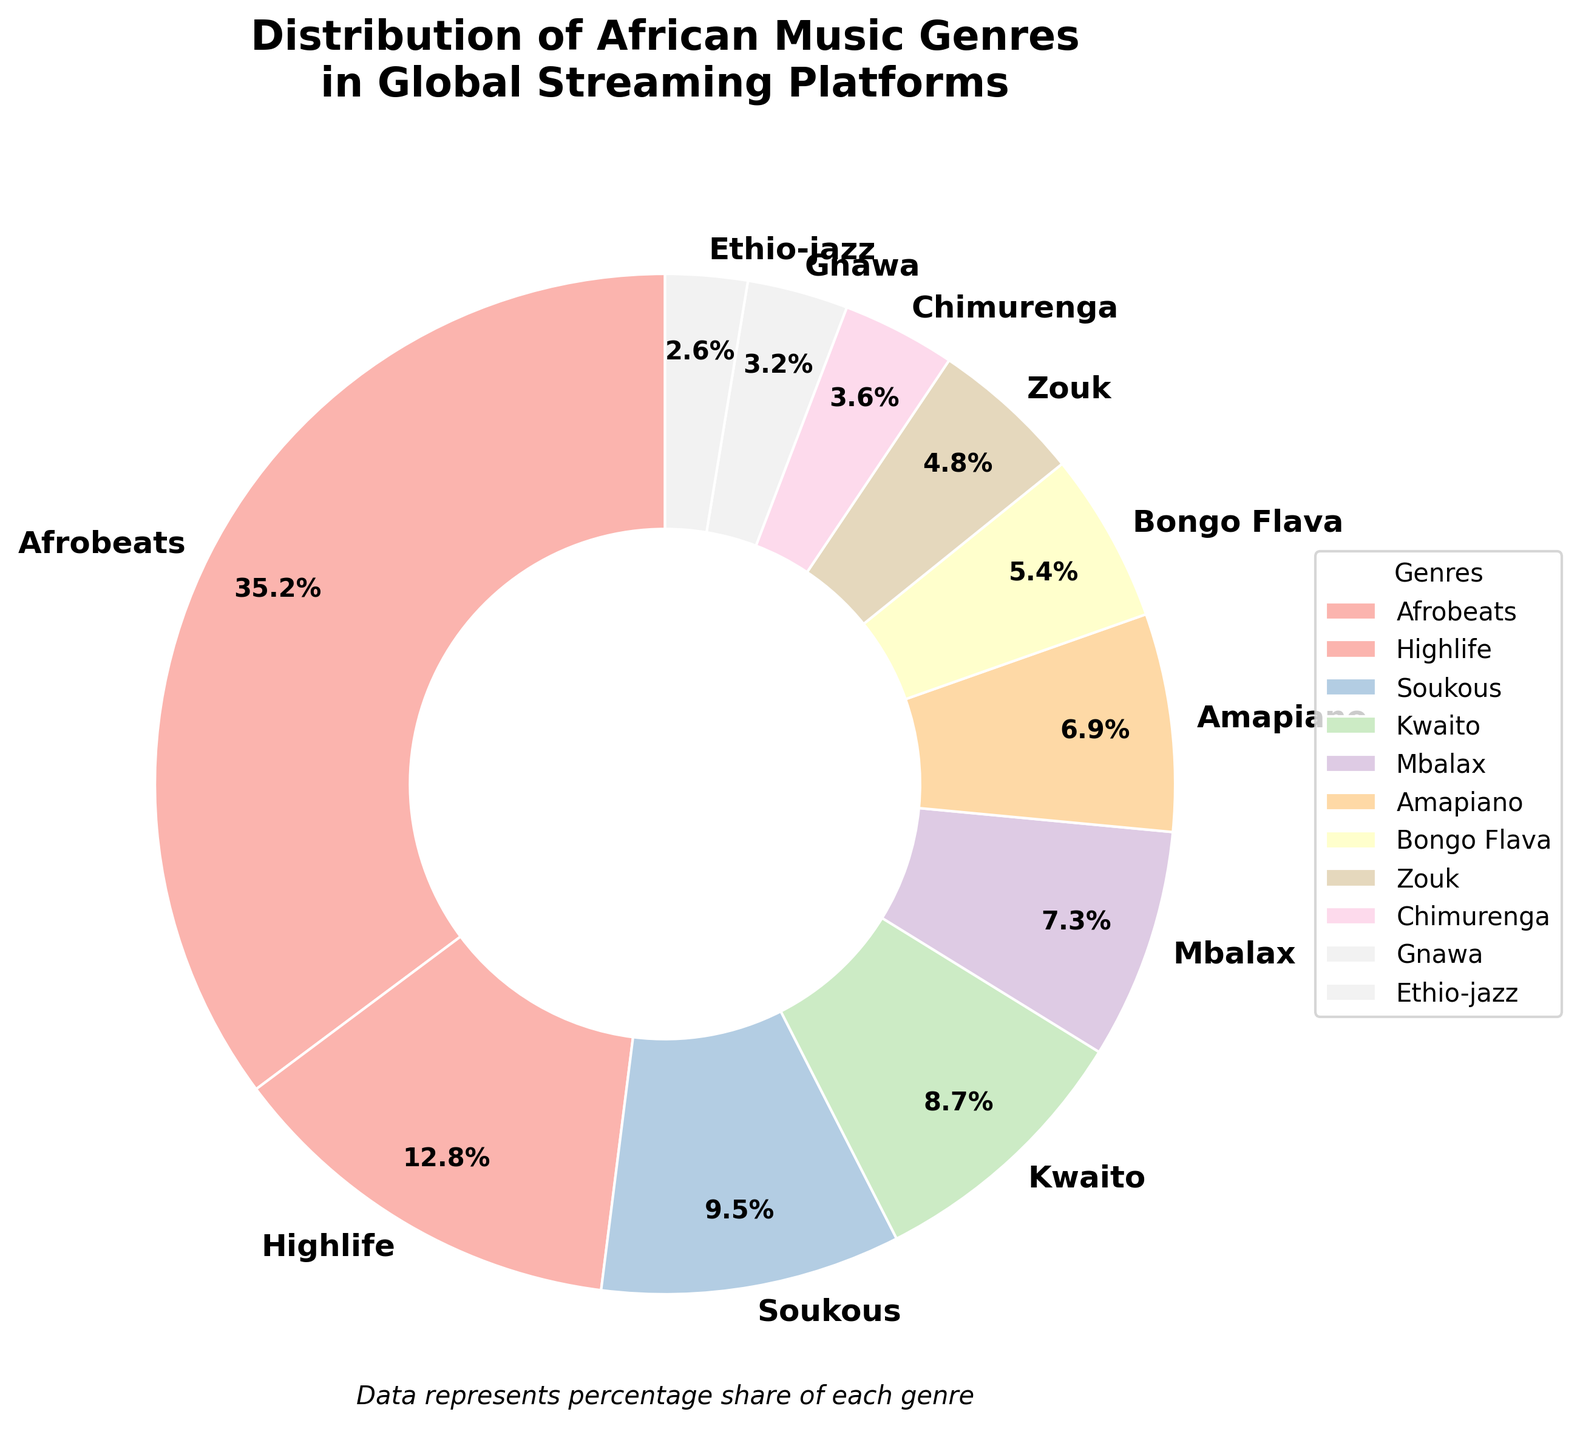Which genre has the highest percentage of distribution in global streaming platforms? The figure shows the percentage distribution of various African music genres. The largest segment of the pie chart represents Afrobeats with 35.2%.
Answer: Afrobeats Which genres have a distribution percentage below 5%? From the lower end of the pie chart, Chimurenga, Gnawa, and Ethio-jazz all have percentages less than 5%: Chimurenga (3.6%), Gnawa (3.2%), and Ethio-jazz (2.6%).
Answer: Chimurenga, Gnawa, Ethio-jazz By how much does the distribution percentage of Highlife exceed that of Kwaito? Highlife has a distribution percentage of 12.8%, while Kwaito has 8.7%. Subtracting these percentages, we get: 12.8% - 8.7% = 4.1%.
Answer: 4.1% What's the combined distribution percentage of Soukous, Kwaito, and Mbalax? Sum the percentages of Soukous (9.5%), Kwaito (8.7%), and Mbalax (7.3%) to get: 9.5% + 8.7% + 7.3% = 25.5%.
Answer: 25.5% Does the share of Amapiano exceed that of Gnawa? Amapiano has a share of 6.9% while Gnawa has 3.2%. Comparing these two, 6.9% > 3.2%.
Answer: Yes Which genre has the smallest wedge in the pie chart? The figure's smallest wedge corresponds to Ethio-jazz with 2.6%.
Answer: Ethio-jazz How do the shares of Highlife and Bongo Flava compare? Highlife has a share of 12.8%, and Bongo Flava has 5.4%. Highlife’s share is larger than Bongo Flava’s share.
Answer: Highlife > Bongo Flava What is the average distribution percentage of Soukous and Zouk? To find the average, sum the percentages of Soukous (9.5%) and Zouk (4.8%) and divide by 2: (9.5% + 4.8%) / 2 = 7.15%.
Answer: 7.15% What is the total percentage share of Afrobeats, Highlife, and Soukous? Sum the percentages of Afrobeats (35.2%), Highlife (12.8%), and Soukous (9.5%) to get: 35.2% + 12.8% + 9.5% = 57.5%.
Answer: 57.5% How much more significant is the share of Afrobeats compared to Ethio-jazz? Afrobeats has a share of 35.2%, and Ethio-jazz has 2.6%. Subtracting these two values, we get: 35.2% - 2.6% = 32.6%.
Answer: 32.6% 